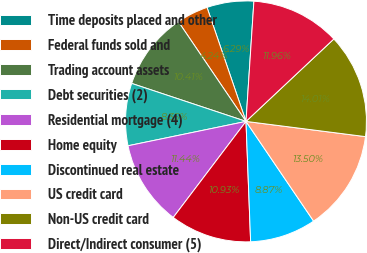<chart> <loc_0><loc_0><loc_500><loc_500><pie_chart><fcel>Time deposits placed and other<fcel>Federal funds sold and<fcel>Trading account assets<fcel>Debt securities (2)<fcel>Residential mortgage (4)<fcel>Home equity<fcel>Discontinued real estate<fcel>US credit card<fcel>Non-US credit card<fcel>Direct/Indirect consumer (5)<nl><fcel>6.29%<fcel>4.24%<fcel>10.41%<fcel>8.35%<fcel>11.44%<fcel>10.93%<fcel>8.87%<fcel>13.5%<fcel>14.01%<fcel>11.96%<nl></chart> 